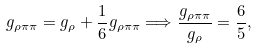Convert formula to latex. <formula><loc_0><loc_0><loc_500><loc_500>g _ { \rho \pi \pi } = g _ { \rho } + \frac { 1 } { 6 } g _ { \rho \pi \pi } \Longrightarrow \frac { g _ { \rho \pi \pi } } { g _ { \rho } } = \frac { 6 } { 5 } ,</formula> 